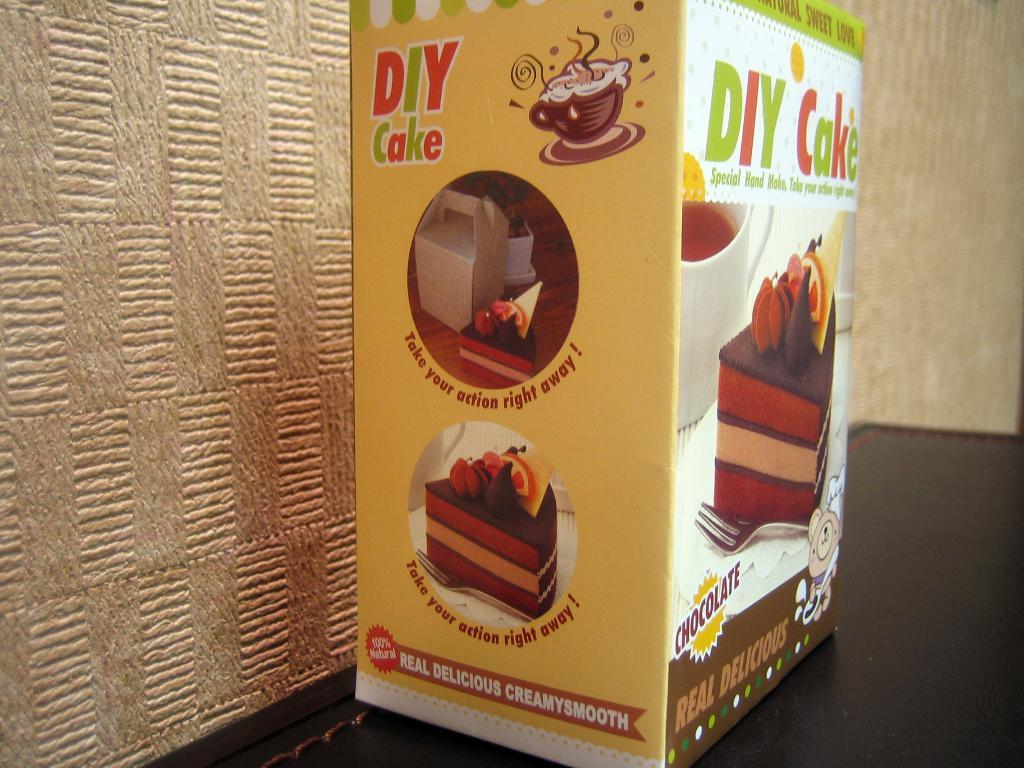What object is on the floor in the image? There is a box on the floor in the image. What is depicted on the box? The box has pictures of cakes on it. What utensil is visible on the box? There is a fork visible on the box. What can be seen on the box besides the pictures and utensil? There is writing on the box. What can be seen in the background of the image? There are walls visible in the background of the image. What grade is the person in the image attending? There is no person visible in the image, so it is impossible to determine the grade they might be attending. 